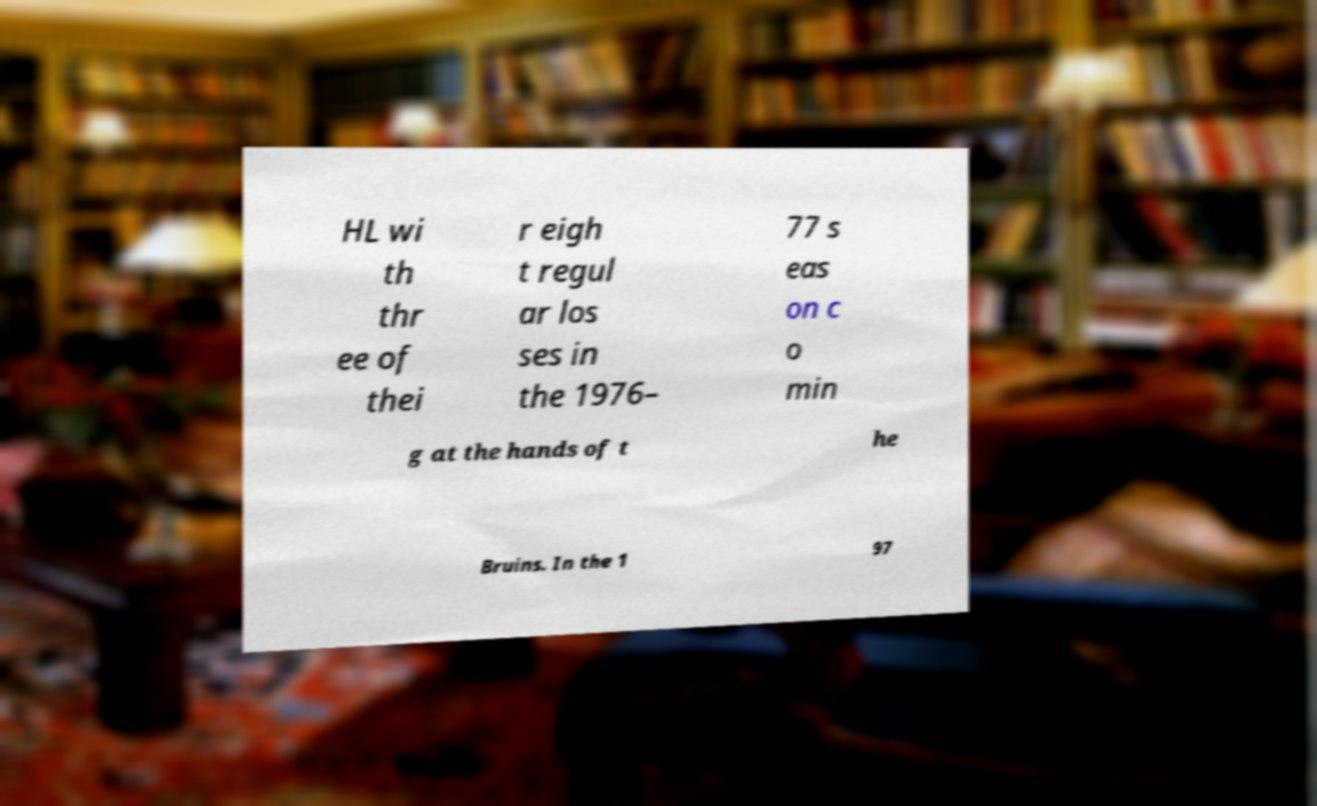Could you extract and type out the text from this image? HL wi th thr ee of thei r eigh t regul ar los ses in the 1976– 77 s eas on c o min g at the hands of t he Bruins. In the 1 97 